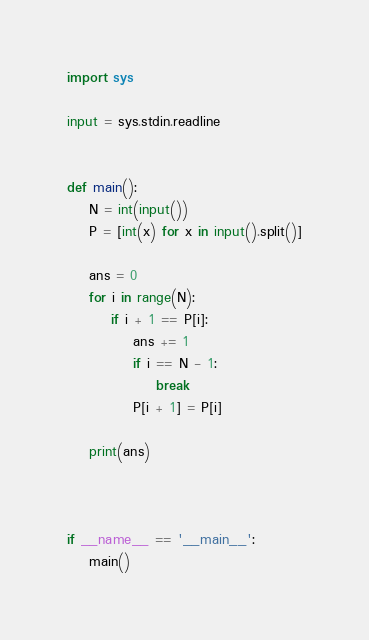<code> <loc_0><loc_0><loc_500><loc_500><_Python_>import sys

input = sys.stdin.readline


def main():
    N = int(input())
    P = [int(x) for x in input().split()]

    ans = 0
    for i in range(N):
        if i + 1 == P[i]:
            ans += 1
            if i == N - 1:
                break
            P[i + 1] = P[i]

    print(ans)
    
    

if __name__ == '__main__':
    main()

</code> 